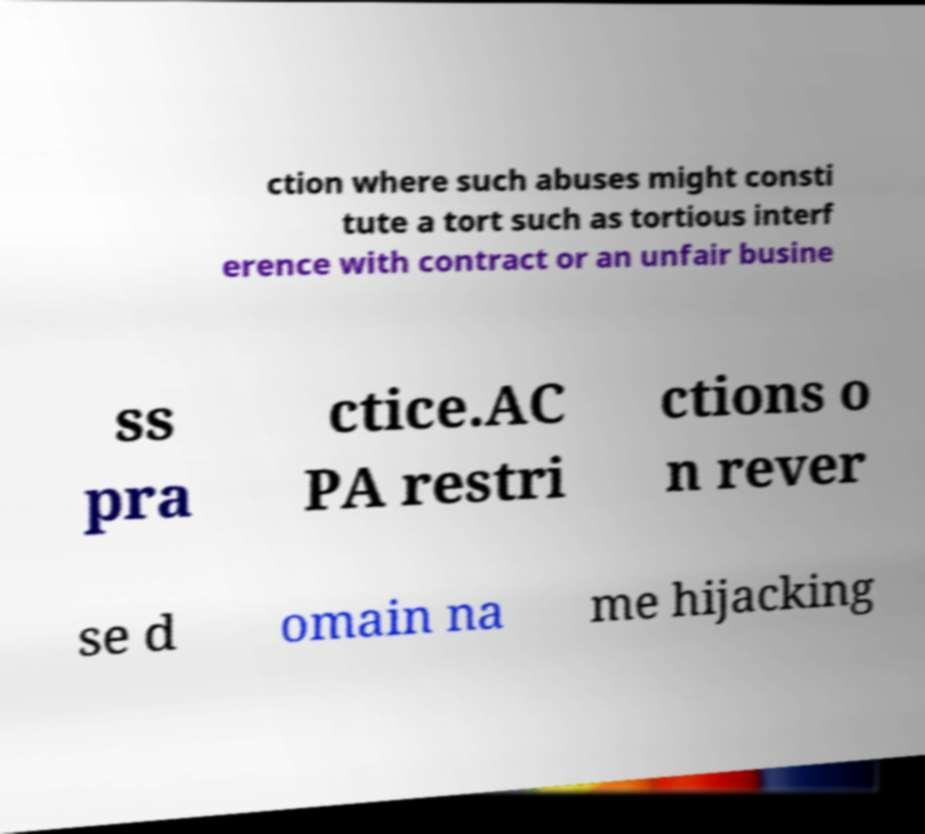Please identify and transcribe the text found in this image. ction where such abuses might consti tute a tort such as tortious interf erence with contract or an unfair busine ss pra ctice.AC PA restri ctions o n rever se d omain na me hijacking 